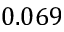<formula> <loc_0><loc_0><loc_500><loc_500>0 . 0 6 9</formula> 